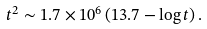Convert formula to latex. <formula><loc_0><loc_0><loc_500><loc_500>t ^ { 2 } \sim 1 . 7 \times 1 0 ^ { 6 } \left ( 1 3 . 7 - \log t \right ) .</formula> 